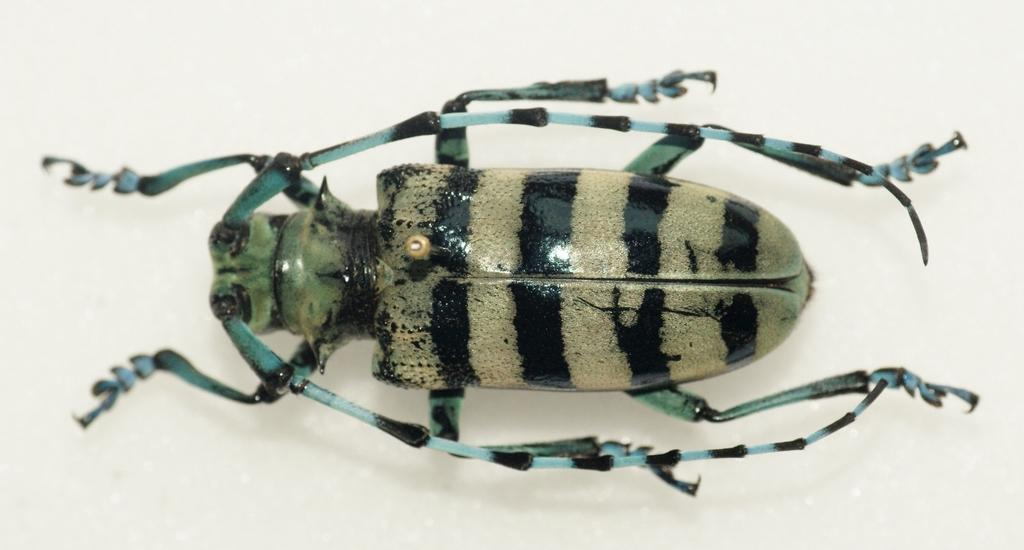What type of creature can be seen in the image? There is an insect in the image. Where is the insect located? The insect is on a platform. Can you tell me how much the insect costs on the receipt in the image? There is no receipt present in the image, and therefore no cost for the insect can be determined. 